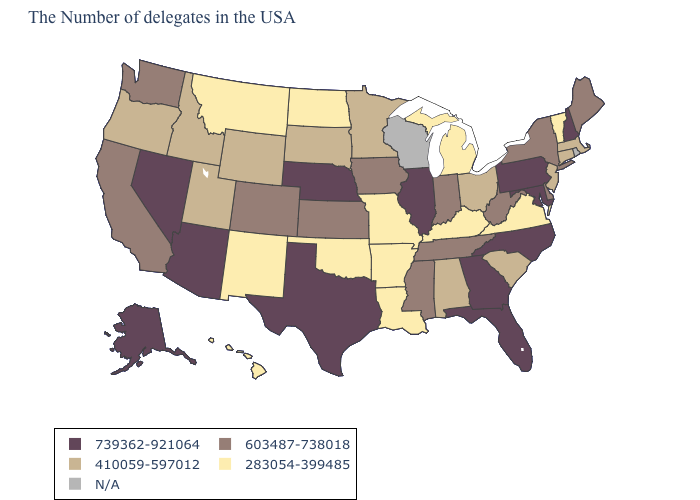Name the states that have a value in the range 739362-921064?
Short answer required. New Hampshire, Maryland, Pennsylvania, North Carolina, Florida, Georgia, Illinois, Nebraska, Texas, Arizona, Nevada, Alaska. What is the value of Texas?
Answer briefly. 739362-921064. Which states have the lowest value in the West?
Write a very short answer. New Mexico, Montana, Hawaii. What is the value of Michigan?
Write a very short answer. 283054-399485. Does Florida have the highest value in the South?
Keep it brief. Yes. What is the highest value in the USA?
Answer briefly. 739362-921064. Is the legend a continuous bar?
Quick response, please. No. What is the lowest value in the USA?
Concise answer only. 283054-399485. Among the states that border New Mexico , does Utah have the highest value?
Answer briefly. No. Name the states that have a value in the range N/A?
Be succinct. Rhode Island, Wisconsin. Name the states that have a value in the range N/A?
Write a very short answer. Rhode Island, Wisconsin. Does the first symbol in the legend represent the smallest category?
Keep it brief. No. Name the states that have a value in the range 410059-597012?
Answer briefly. Massachusetts, Connecticut, New Jersey, South Carolina, Ohio, Alabama, Minnesota, South Dakota, Wyoming, Utah, Idaho, Oregon. 